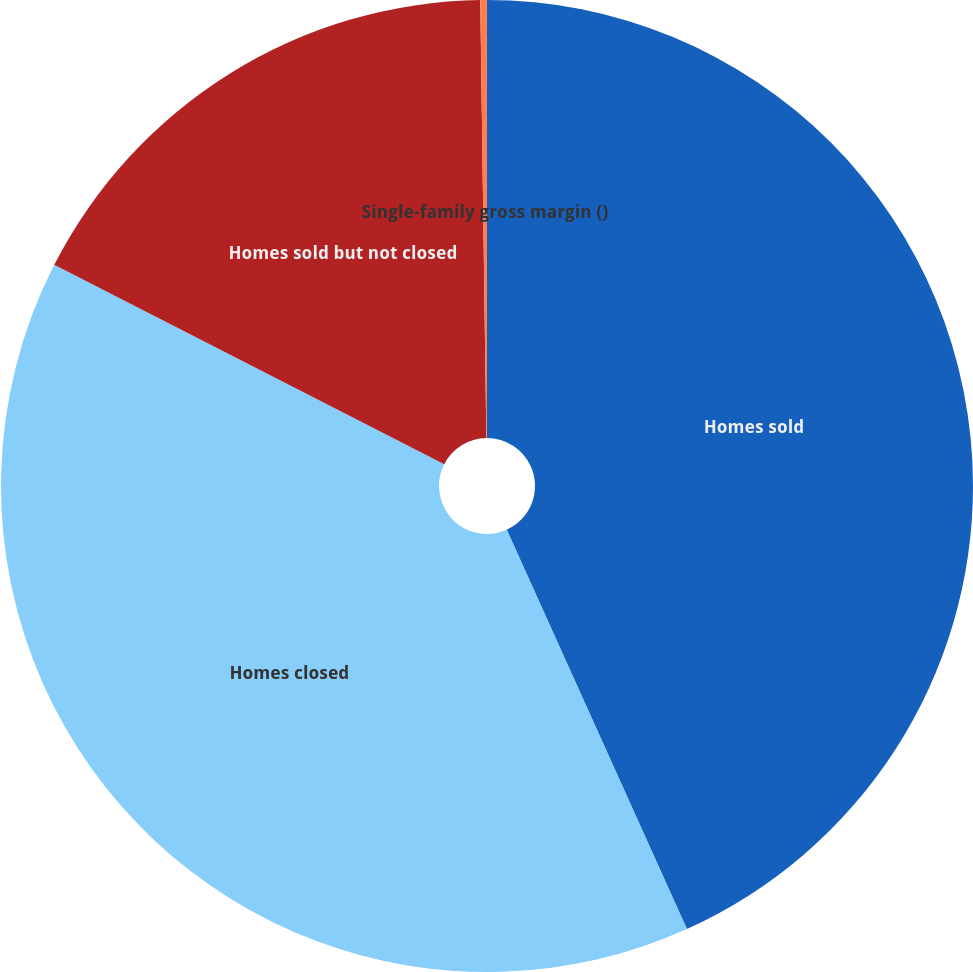Convert chart. <chart><loc_0><loc_0><loc_500><loc_500><pie_chart><fcel>Homes sold<fcel>Homes closed<fcel>Homes sold but not closed<fcel>Single-family gross margin ()<nl><fcel>43.25%<fcel>39.26%<fcel>17.26%<fcel>0.22%<nl></chart> 